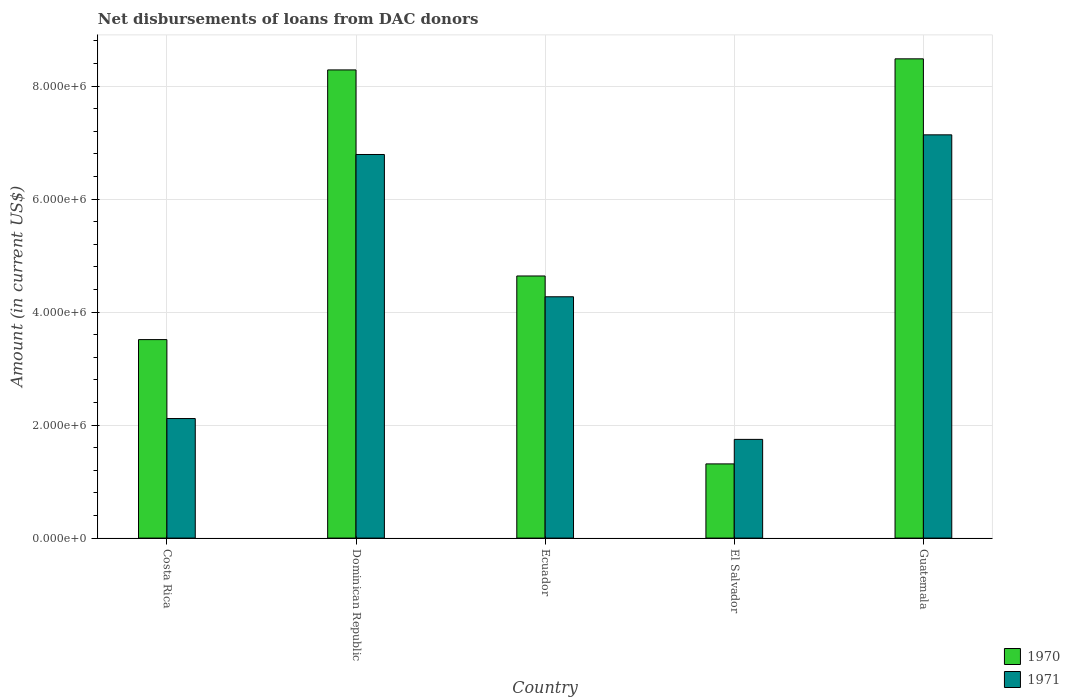Are the number of bars per tick equal to the number of legend labels?
Give a very brief answer. Yes. How many bars are there on the 1st tick from the left?
Offer a very short reply. 2. What is the label of the 2nd group of bars from the left?
Make the answer very short. Dominican Republic. What is the amount of loans disbursed in 1971 in Guatemala?
Provide a succinct answer. 7.14e+06. Across all countries, what is the maximum amount of loans disbursed in 1970?
Your response must be concise. 8.48e+06. Across all countries, what is the minimum amount of loans disbursed in 1971?
Provide a succinct answer. 1.75e+06. In which country was the amount of loans disbursed in 1970 maximum?
Your response must be concise. Guatemala. In which country was the amount of loans disbursed in 1971 minimum?
Offer a very short reply. El Salvador. What is the total amount of loans disbursed in 1971 in the graph?
Your answer should be compact. 2.21e+07. What is the difference between the amount of loans disbursed in 1970 in El Salvador and that in Guatemala?
Offer a terse response. -7.17e+06. What is the difference between the amount of loans disbursed in 1970 in El Salvador and the amount of loans disbursed in 1971 in Ecuador?
Your response must be concise. -2.96e+06. What is the average amount of loans disbursed in 1971 per country?
Ensure brevity in your answer.  4.41e+06. What is the difference between the amount of loans disbursed of/in 1970 and amount of loans disbursed of/in 1971 in Ecuador?
Ensure brevity in your answer.  3.68e+05. In how many countries, is the amount of loans disbursed in 1971 greater than 3200000 US$?
Give a very brief answer. 3. What is the ratio of the amount of loans disbursed in 1970 in Dominican Republic to that in Ecuador?
Give a very brief answer. 1.79. Is the difference between the amount of loans disbursed in 1970 in Ecuador and Guatemala greater than the difference between the amount of loans disbursed in 1971 in Ecuador and Guatemala?
Provide a short and direct response. No. What is the difference between the highest and the second highest amount of loans disbursed in 1970?
Offer a terse response. 3.84e+06. What is the difference between the highest and the lowest amount of loans disbursed in 1970?
Keep it short and to the point. 7.17e+06. In how many countries, is the amount of loans disbursed in 1970 greater than the average amount of loans disbursed in 1970 taken over all countries?
Offer a terse response. 2. What does the 2nd bar from the left in Dominican Republic represents?
Offer a terse response. 1971. What does the 1st bar from the right in El Salvador represents?
Your answer should be compact. 1971. How many countries are there in the graph?
Give a very brief answer. 5. Are the values on the major ticks of Y-axis written in scientific E-notation?
Your answer should be very brief. Yes. Does the graph contain any zero values?
Your answer should be very brief. No. Does the graph contain grids?
Provide a succinct answer. Yes. Where does the legend appear in the graph?
Keep it short and to the point. Bottom right. What is the title of the graph?
Offer a very short reply. Net disbursements of loans from DAC donors. What is the label or title of the X-axis?
Your answer should be very brief. Country. What is the Amount (in current US$) in 1970 in Costa Rica?
Provide a short and direct response. 3.51e+06. What is the Amount (in current US$) of 1971 in Costa Rica?
Provide a succinct answer. 2.12e+06. What is the Amount (in current US$) in 1970 in Dominican Republic?
Ensure brevity in your answer.  8.29e+06. What is the Amount (in current US$) in 1971 in Dominican Republic?
Make the answer very short. 6.79e+06. What is the Amount (in current US$) of 1970 in Ecuador?
Keep it short and to the point. 4.64e+06. What is the Amount (in current US$) of 1971 in Ecuador?
Offer a terse response. 4.27e+06. What is the Amount (in current US$) in 1970 in El Salvador?
Offer a terse response. 1.31e+06. What is the Amount (in current US$) in 1971 in El Salvador?
Your response must be concise. 1.75e+06. What is the Amount (in current US$) of 1970 in Guatemala?
Ensure brevity in your answer.  8.48e+06. What is the Amount (in current US$) in 1971 in Guatemala?
Your answer should be compact. 7.14e+06. Across all countries, what is the maximum Amount (in current US$) of 1970?
Provide a succinct answer. 8.48e+06. Across all countries, what is the maximum Amount (in current US$) in 1971?
Ensure brevity in your answer.  7.14e+06. Across all countries, what is the minimum Amount (in current US$) of 1970?
Your answer should be very brief. 1.31e+06. Across all countries, what is the minimum Amount (in current US$) of 1971?
Your response must be concise. 1.75e+06. What is the total Amount (in current US$) of 1970 in the graph?
Provide a short and direct response. 2.62e+07. What is the total Amount (in current US$) in 1971 in the graph?
Your answer should be very brief. 2.21e+07. What is the difference between the Amount (in current US$) in 1970 in Costa Rica and that in Dominican Republic?
Offer a terse response. -4.77e+06. What is the difference between the Amount (in current US$) of 1971 in Costa Rica and that in Dominican Republic?
Ensure brevity in your answer.  -4.67e+06. What is the difference between the Amount (in current US$) of 1970 in Costa Rica and that in Ecuador?
Give a very brief answer. -1.13e+06. What is the difference between the Amount (in current US$) in 1971 in Costa Rica and that in Ecuador?
Your answer should be very brief. -2.16e+06. What is the difference between the Amount (in current US$) in 1970 in Costa Rica and that in El Salvador?
Your answer should be very brief. 2.20e+06. What is the difference between the Amount (in current US$) of 1971 in Costa Rica and that in El Salvador?
Your answer should be compact. 3.69e+05. What is the difference between the Amount (in current US$) of 1970 in Costa Rica and that in Guatemala?
Keep it short and to the point. -4.97e+06. What is the difference between the Amount (in current US$) of 1971 in Costa Rica and that in Guatemala?
Keep it short and to the point. -5.02e+06. What is the difference between the Amount (in current US$) of 1970 in Dominican Republic and that in Ecuador?
Provide a short and direct response. 3.65e+06. What is the difference between the Amount (in current US$) in 1971 in Dominican Republic and that in Ecuador?
Keep it short and to the point. 2.52e+06. What is the difference between the Amount (in current US$) in 1970 in Dominican Republic and that in El Salvador?
Your answer should be very brief. 6.97e+06. What is the difference between the Amount (in current US$) of 1971 in Dominican Republic and that in El Salvador?
Offer a terse response. 5.04e+06. What is the difference between the Amount (in current US$) in 1970 in Dominican Republic and that in Guatemala?
Provide a short and direct response. -1.96e+05. What is the difference between the Amount (in current US$) of 1971 in Dominican Republic and that in Guatemala?
Your answer should be very brief. -3.48e+05. What is the difference between the Amount (in current US$) of 1970 in Ecuador and that in El Salvador?
Ensure brevity in your answer.  3.33e+06. What is the difference between the Amount (in current US$) in 1971 in Ecuador and that in El Salvador?
Ensure brevity in your answer.  2.52e+06. What is the difference between the Amount (in current US$) of 1970 in Ecuador and that in Guatemala?
Your answer should be compact. -3.84e+06. What is the difference between the Amount (in current US$) of 1971 in Ecuador and that in Guatemala?
Ensure brevity in your answer.  -2.87e+06. What is the difference between the Amount (in current US$) of 1970 in El Salvador and that in Guatemala?
Provide a succinct answer. -7.17e+06. What is the difference between the Amount (in current US$) of 1971 in El Salvador and that in Guatemala?
Ensure brevity in your answer.  -5.39e+06. What is the difference between the Amount (in current US$) of 1970 in Costa Rica and the Amount (in current US$) of 1971 in Dominican Republic?
Your answer should be very brief. -3.28e+06. What is the difference between the Amount (in current US$) of 1970 in Costa Rica and the Amount (in current US$) of 1971 in Ecuador?
Your answer should be very brief. -7.58e+05. What is the difference between the Amount (in current US$) in 1970 in Costa Rica and the Amount (in current US$) in 1971 in El Salvador?
Provide a succinct answer. 1.77e+06. What is the difference between the Amount (in current US$) of 1970 in Costa Rica and the Amount (in current US$) of 1971 in Guatemala?
Offer a terse response. -3.62e+06. What is the difference between the Amount (in current US$) of 1970 in Dominican Republic and the Amount (in current US$) of 1971 in Ecuador?
Provide a short and direct response. 4.02e+06. What is the difference between the Amount (in current US$) of 1970 in Dominican Republic and the Amount (in current US$) of 1971 in El Salvador?
Offer a very short reply. 6.54e+06. What is the difference between the Amount (in current US$) of 1970 in Dominican Republic and the Amount (in current US$) of 1971 in Guatemala?
Offer a terse response. 1.15e+06. What is the difference between the Amount (in current US$) in 1970 in Ecuador and the Amount (in current US$) in 1971 in El Salvador?
Your response must be concise. 2.89e+06. What is the difference between the Amount (in current US$) in 1970 in Ecuador and the Amount (in current US$) in 1971 in Guatemala?
Ensure brevity in your answer.  -2.50e+06. What is the difference between the Amount (in current US$) of 1970 in El Salvador and the Amount (in current US$) of 1971 in Guatemala?
Make the answer very short. -5.82e+06. What is the average Amount (in current US$) of 1970 per country?
Provide a succinct answer. 5.25e+06. What is the average Amount (in current US$) of 1971 per country?
Your answer should be very brief. 4.41e+06. What is the difference between the Amount (in current US$) of 1970 and Amount (in current US$) of 1971 in Costa Rica?
Make the answer very short. 1.40e+06. What is the difference between the Amount (in current US$) of 1970 and Amount (in current US$) of 1971 in Dominican Republic?
Provide a succinct answer. 1.50e+06. What is the difference between the Amount (in current US$) in 1970 and Amount (in current US$) in 1971 in Ecuador?
Provide a short and direct response. 3.68e+05. What is the difference between the Amount (in current US$) in 1970 and Amount (in current US$) in 1971 in El Salvador?
Give a very brief answer. -4.34e+05. What is the difference between the Amount (in current US$) of 1970 and Amount (in current US$) of 1971 in Guatemala?
Keep it short and to the point. 1.34e+06. What is the ratio of the Amount (in current US$) in 1970 in Costa Rica to that in Dominican Republic?
Make the answer very short. 0.42. What is the ratio of the Amount (in current US$) of 1971 in Costa Rica to that in Dominican Republic?
Ensure brevity in your answer.  0.31. What is the ratio of the Amount (in current US$) of 1970 in Costa Rica to that in Ecuador?
Provide a succinct answer. 0.76. What is the ratio of the Amount (in current US$) of 1971 in Costa Rica to that in Ecuador?
Your response must be concise. 0.5. What is the ratio of the Amount (in current US$) in 1970 in Costa Rica to that in El Salvador?
Offer a very short reply. 2.68. What is the ratio of the Amount (in current US$) of 1971 in Costa Rica to that in El Salvador?
Ensure brevity in your answer.  1.21. What is the ratio of the Amount (in current US$) of 1970 in Costa Rica to that in Guatemala?
Make the answer very short. 0.41. What is the ratio of the Amount (in current US$) in 1971 in Costa Rica to that in Guatemala?
Ensure brevity in your answer.  0.3. What is the ratio of the Amount (in current US$) in 1970 in Dominican Republic to that in Ecuador?
Offer a terse response. 1.79. What is the ratio of the Amount (in current US$) of 1971 in Dominican Republic to that in Ecuador?
Keep it short and to the point. 1.59. What is the ratio of the Amount (in current US$) of 1970 in Dominican Republic to that in El Salvador?
Ensure brevity in your answer.  6.31. What is the ratio of the Amount (in current US$) in 1971 in Dominican Republic to that in El Salvador?
Provide a succinct answer. 3.89. What is the ratio of the Amount (in current US$) in 1970 in Dominican Republic to that in Guatemala?
Offer a very short reply. 0.98. What is the ratio of the Amount (in current US$) in 1971 in Dominican Republic to that in Guatemala?
Your answer should be compact. 0.95. What is the ratio of the Amount (in current US$) in 1970 in Ecuador to that in El Salvador?
Ensure brevity in your answer.  3.53. What is the ratio of the Amount (in current US$) of 1971 in Ecuador to that in El Salvador?
Your response must be concise. 2.44. What is the ratio of the Amount (in current US$) of 1970 in Ecuador to that in Guatemala?
Your answer should be very brief. 0.55. What is the ratio of the Amount (in current US$) in 1971 in Ecuador to that in Guatemala?
Offer a terse response. 0.6. What is the ratio of the Amount (in current US$) of 1970 in El Salvador to that in Guatemala?
Ensure brevity in your answer.  0.15. What is the ratio of the Amount (in current US$) in 1971 in El Salvador to that in Guatemala?
Provide a short and direct response. 0.24. What is the difference between the highest and the second highest Amount (in current US$) of 1970?
Your answer should be very brief. 1.96e+05. What is the difference between the highest and the second highest Amount (in current US$) of 1971?
Give a very brief answer. 3.48e+05. What is the difference between the highest and the lowest Amount (in current US$) in 1970?
Provide a succinct answer. 7.17e+06. What is the difference between the highest and the lowest Amount (in current US$) of 1971?
Your response must be concise. 5.39e+06. 